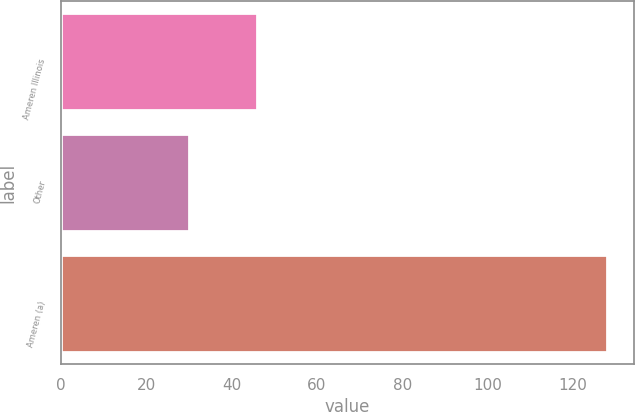Convert chart to OTSL. <chart><loc_0><loc_0><loc_500><loc_500><bar_chart><fcel>Ameren Illinois<fcel>Other<fcel>Ameren (a)<nl><fcel>46<fcel>30<fcel>128<nl></chart> 